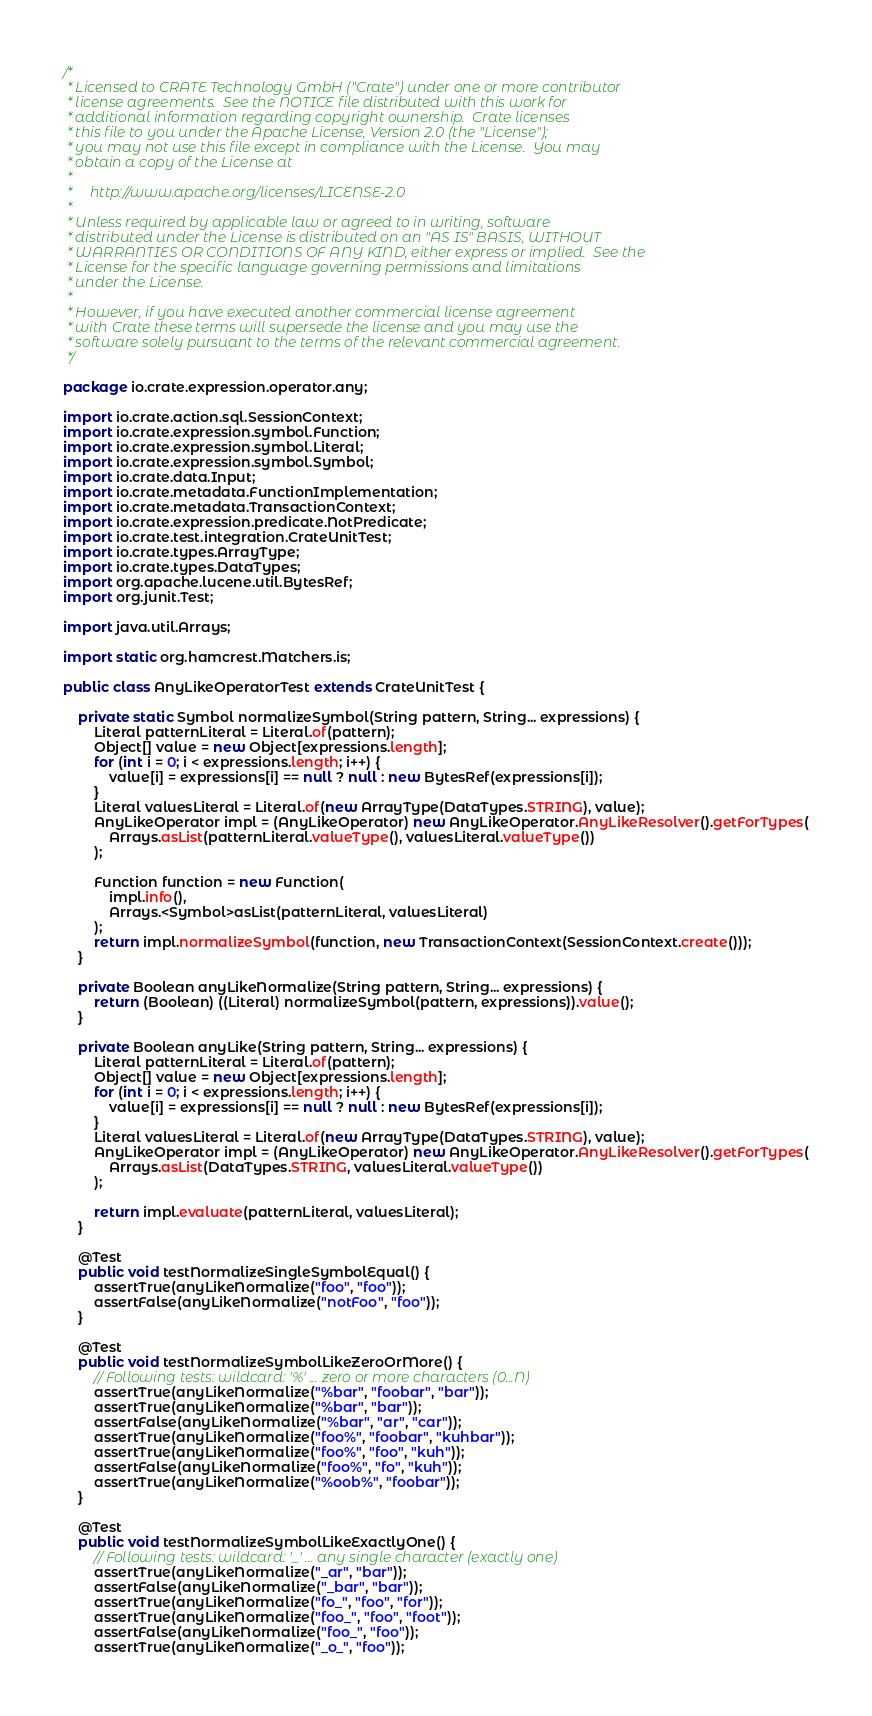<code> <loc_0><loc_0><loc_500><loc_500><_Java_>/*
 * Licensed to CRATE Technology GmbH ("Crate") under one or more contributor
 * license agreements.  See the NOTICE file distributed with this work for
 * additional information regarding copyright ownership.  Crate licenses
 * this file to you under the Apache License, Version 2.0 (the "License");
 * you may not use this file except in compliance with the License.  You may
 * obtain a copy of the License at
 *
 *     http://www.apache.org/licenses/LICENSE-2.0
 *
 * Unless required by applicable law or agreed to in writing, software
 * distributed under the License is distributed on an "AS IS" BASIS, WITHOUT
 * WARRANTIES OR CONDITIONS OF ANY KIND, either express or implied.  See the
 * License for the specific language governing permissions and limitations
 * under the License.
 *
 * However, if you have executed another commercial license agreement
 * with Crate these terms will supersede the license and you may use the
 * software solely pursuant to the terms of the relevant commercial agreement.
 */

package io.crate.expression.operator.any;

import io.crate.action.sql.SessionContext;
import io.crate.expression.symbol.Function;
import io.crate.expression.symbol.Literal;
import io.crate.expression.symbol.Symbol;
import io.crate.data.Input;
import io.crate.metadata.FunctionImplementation;
import io.crate.metadata.TransactionContext;
import io.crate.expression.predicate.NotPredicate;
import io.crate.test.integration.CrateUnitTest;
import io.crate.types.ArrayType;
import io.crate.types.DataTypes;
import org.apache.lucene.util.BytesRef;
import org.junit.Test;

import java.util.Arrays;

import static org.hamcrest.Matchers.is;

public class AnyLikeOperatorTest extends CrateUnitTest {

    private static Symbol normalizeSymbol(String pattern, String... expressions) {
        Literal patternLiteral = Literal.of(pattern);
        Object[] value = new Object[expressions.length];
        for (int i = 0; i < expressions.length; i++) {
            value[i] = expressions[i] == null ? null : new BytesRef(expressions[i]);
        }
        Literal valuesLiteral = Literal.of(new ArrayType(DataTypes.STRING), value);
        AnyLikeOperator impl = (AnyLikeOperator) new AnyLikeOperator.AnyLikeResolver().getForTypes(
            Arrays.asList(patternLiteral.valueType(), valuesLiteral.valueType())
        );

        Function function = new Function(
            impl.info(),
            Arrays.<Symbol>asList(patternLiteral, valuesLiteral)
        );
        return impl.normalizeSymbol(function, new TransactionContext(SessionContext.create()));
    }

    private Boolean anyLikeNormalize(String pattern, String... expressions) {
        return (Boolean) ((Literal) normalizeSymbol(pattern, expressions)).value();
    }

    private Boolean anyLike(String pattern, String... expressions) {
        Literal patternLiteral = Literal.of(pattern);
        Object[] value = new Object[expressions.length];
        for (int i = 0; i < expressions.length; i++) {
            value[i] = expressions[i] == null ? null : new BytesRef(expressions[i]);
        }
        Literal valuesLiteral = Literal.of(new ArrayType(DataTypes.STRING), value);
        AnyLikeOperator impl = (AnyLikeOperator) new AnyLikeOperator.AnyLikeResolver().getForTypes(
            Arrays.asList(DataTypes.STRING, valuesLiteral.valueType())
        );

        return impl.evaluate(patternLiteral, valuesLiteral);
    }

    @Test
    public void testNormalizeSingleSymbolEqual() {
        assertTrue(anyLikeNormalize("foo", "foo"));
        assertFalse(anyLikeNormalize("notFoo", "foo"));
    }

    @Test
    public void testNormalizeSymbolLikeZeroOrMore() {
        // Following tests: wildcard: '%' ... zero or more characters (0...N)
        assertTrue(anyLikeNormalize("%bar", "foobar", "bar"));
        assertTrue(anyLikeNormalize("%bar", "bar"));
        assertFalse(anyLikeNormalize("%bar", "ar", "car"));
        assertTrue(anyLikeNormalize("foo%", "foobar", "kuhbar"));
        assertTrue(anyLikeNormalize("foo%", "foo", "kuh"));
        assertFalse(anyLikeNormalize("foo%", "fo", "kuh"));
        assertTrue(anyLikeNormalize("%oob%", "foobar"));
    }

    @Test
    public void testNormalizeSymbolLikeExactlyOne() {
        // Following tests: wildcard: '_' ... any single character (exactly one)
        assertTrue(anyLikeNormalize("_ar", "bar"));
        assertFalse(anyLikeNormalize("_bar", "bar"));
        assertTrue(anyLikeNormalize("fo_", "foo", "for"));
        assertTrue(anyLikeNormalize("foo_", "foo", "foot"));
        assertFalse(anyLikeNormalize("foo_", "foo"));
        assertTrue(anyLikeNormalize("_o_", "foo"));</code> 